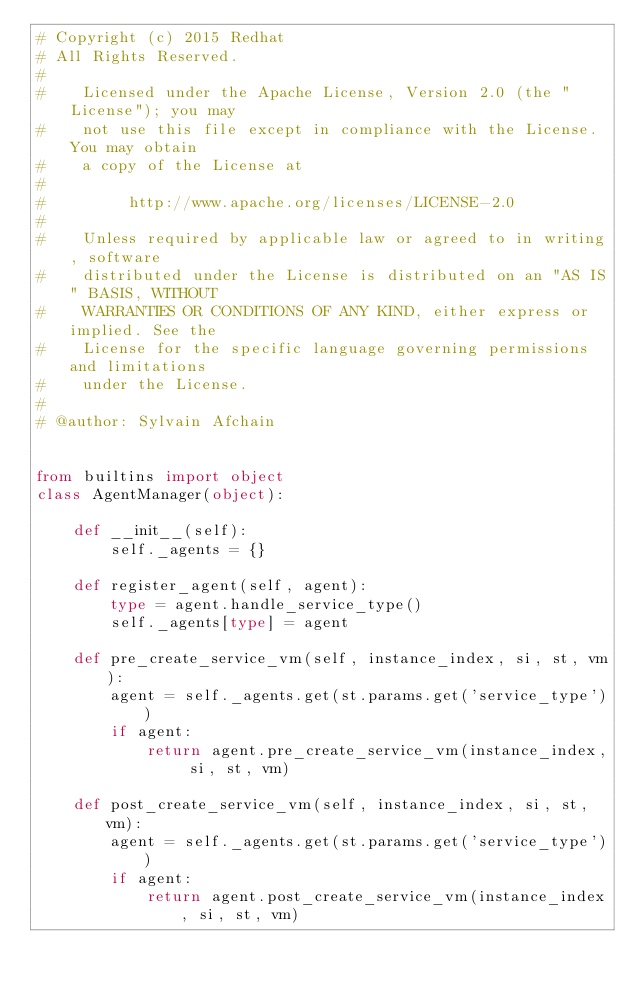Convert code to text. <code><loc_0><loc_0><loc_500><loc_500><_Python_># Copyright (c) 2015 Redhat
# All Rights Reserved.
#
#    Licensed under the Apache License, Version 2.0 (the "License"); you may
#    not use this file except in compliance with the License. You may obtain
#    a copy of the License at
#
#         http://www.apache.org/licenses/LICENSE-2.0
#
#    Unless required by applicable law or agreed to in writing, software
#    distributed under the License is distributed on an "AS IS" BASIS, WITHOUT
#    WARRANTIES OR CONDITIONS OF ANY KIND, either express or implied. See the
#    License for the specific language governing permissions and limitations
#    under the License.
#
# @author: Sylvain Afchain


from builtins import object
class AgentManager(object):

    def __init__(self):
        self._agents = {}

    def register_agent(self, agent):
        type = agent.handle_service_type()
        self._agents[type] = agent

    def pre_create_service_vm(self, instance_index, si, st, vm):
        agent = self._agents.get(st.params.get('service_type'))
        if agent:
            return agent.pre_create_service_vm(instance_index, si, st, vm)

    def post_create_service_vm(self, instance_index, si, st, vm):
        agent = self._agents.get(st.params.get('service_type'))
        if agent:
            return agent.post_create_service_vm(instance_index, si, st, vm)
</code> 